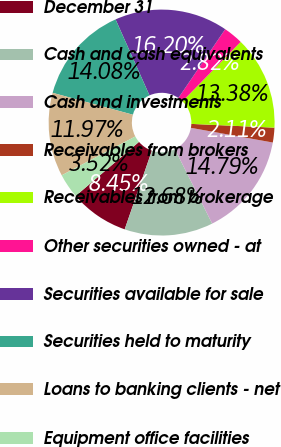Convert chart to OTSL. <chart><loc_0><loc_0><loc_500><loc_500><pie_chart><fcel>December 31<fcel>Cash and cash equivalents<fcel>Cash and investments<fcel>Receivables from brokers<fcel>Receivables from brokerage<fcel>Other securities owned - at<fcel>Securities available for sale<fcel>Securities held to maturity<fcel>Loans to banking clients - net<fcel>Equipment office facilities<nl><fcel>8.45%<fcel>12.68%<fcel>14.79%<fcel>2.11%<fcel>13.38%<fcel>2.82%<fcel>16.2%<fcel>14.08%<fcel>11.97%<fcel>3.52%<nl></chart> 